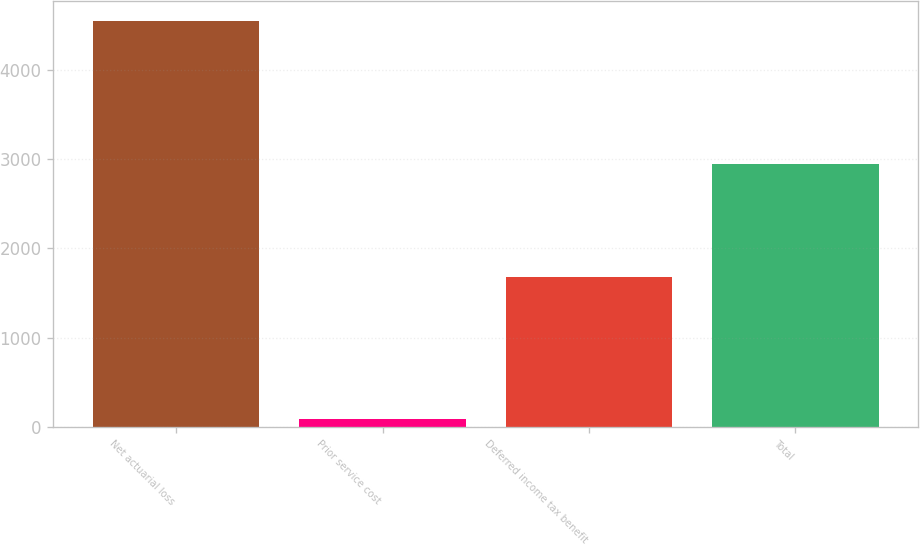<chart> <loc_0><loc_0><loc_500><loc_500><bar_chart><fcel>Net actuarial loss<fcel>Prior service cost<fcel>Deferred income tax benefit<fcel>Total<nl><fcel>4545<fcel>88<fcel>1684<fcel>2949<nl></chart> 